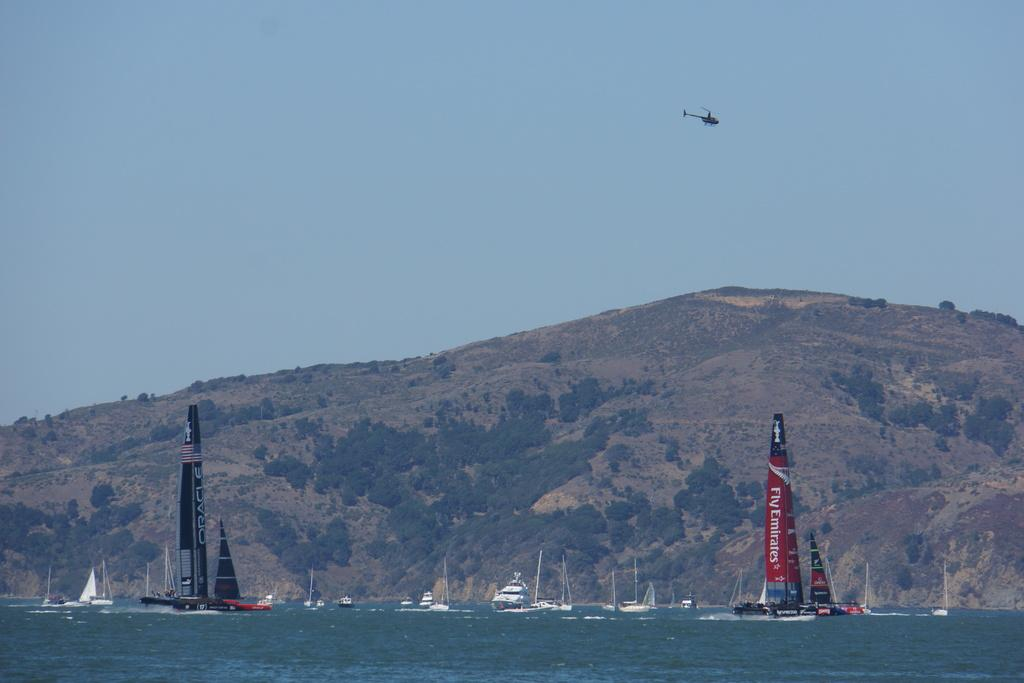<image>
Render a clear and concise summary of the photo. A lake has lots of boats in it including a sail boat that says Fly Emirates on the sail. 